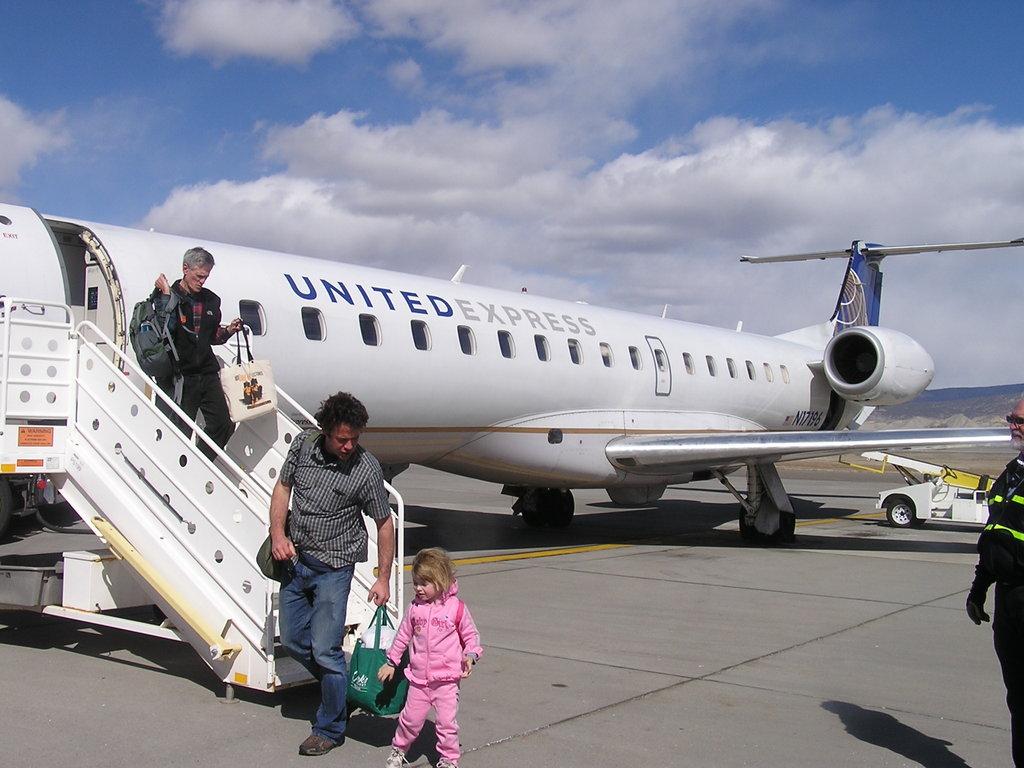Where did the plane come from?
Keep it short and to the point. Unanswerable. What airline is this?
Offer a very short reply. United express. 